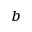Convert formula to latex. <formula><loc_0><loc_0><loc_500><loc_500>^ { b }</formula> 